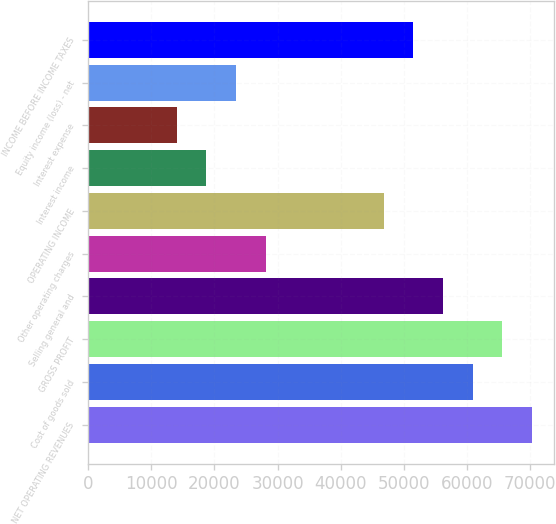<chart> <loc_0><loc_0><loc_500><loc_500><bar_chart><fcel>NET OPERATING REVENUES<fcel>Cost of goods sold<fcel>GROSS PROFIT<fcel>Selling general and<fcel>Other operating charges<fcel>OPERATING INCOME<fcel>Interest income<fcel>Interest expense<fcel>Equity income (loss) - net<fcel>INCOME BEFORE INCOME TAXES<nl><fcel>70280.1<fcel>60909.6<fcel>65594.8<fcel>56224.4<fcel>28113.2<fcel>46854<fcel>18742.7<fcel>14057.5<fcel>23428<fcel>51539.2<nl></chart> 